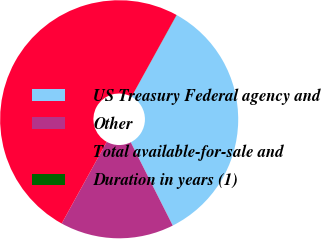Convert chart. <chart><loc_0><loc_0><loc_500><loc_500><pie_chart><fcel>US Treasury Federal agency and<fcel>Other<fcel>Total available-for-sale and<fcel>Duration in years (1)<nl><fcel>34.54%<fcel>15.45%<fcel>49.99%<fcel>0.02%<nl></chart> 